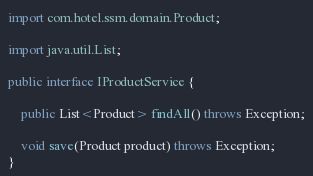Convert code to text. <code><loc_0><loc_0><loc_500><loc_500><_Java_>
import com.hotel.ssm.domain.Product;

import java.util.List;

public interface IProductService {

    public List<Product> findAll() throws Exception;

    void save(Product product) throws Exception;
}
</code> 